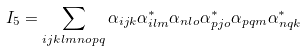Convert formula to latex. <formula><loc_0><loc_0><loc_500><loc_500>I _ { 5 } = \sum _ { i j k l m n o p q } \alpha _ { i j k } \alpha _ { i l m } ^ { \ast } \alpha _ { n l o } \alpha _ { p j o } ^ { \ast } \alpha _ { p q m } \alpha _ { n q k } ^ { \ast }</formula> 